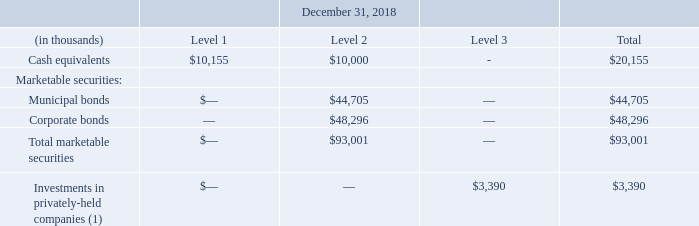(1) Included in other long-term assets.
For certain other financial instruments, including accounts receivable, unbilled receivables, and accounts payable, the carrying value approximates fair value due to the relatively short maturity of these items.
Where are investments in privately-held companies classified under? Included in other long-term assets. What are the respective Level 1 and Level 2 cash equivalents as at December 31, 2018? $10,155, $10,000. What are the respective Level 2 municipal and corporate bonds as at December 31, 2018? $44,705, $48,296. What is the value of Level 1 cash equivalents as a percentage of the total cash equivalents?
Answer scale should be: percent. 10,155/20,155 
Answer: 50.38. What is the value of Level 2 municipal bonds as a percentage of the total municipal bonds?
Answer scale should be: percent. 44,705/44,705 
Answer: 100. What is the value of municipal bonds as a percentage of the total marketable securities?
Answer scale should be: percent. 44,705/93,001 
Answer: 48.07. 